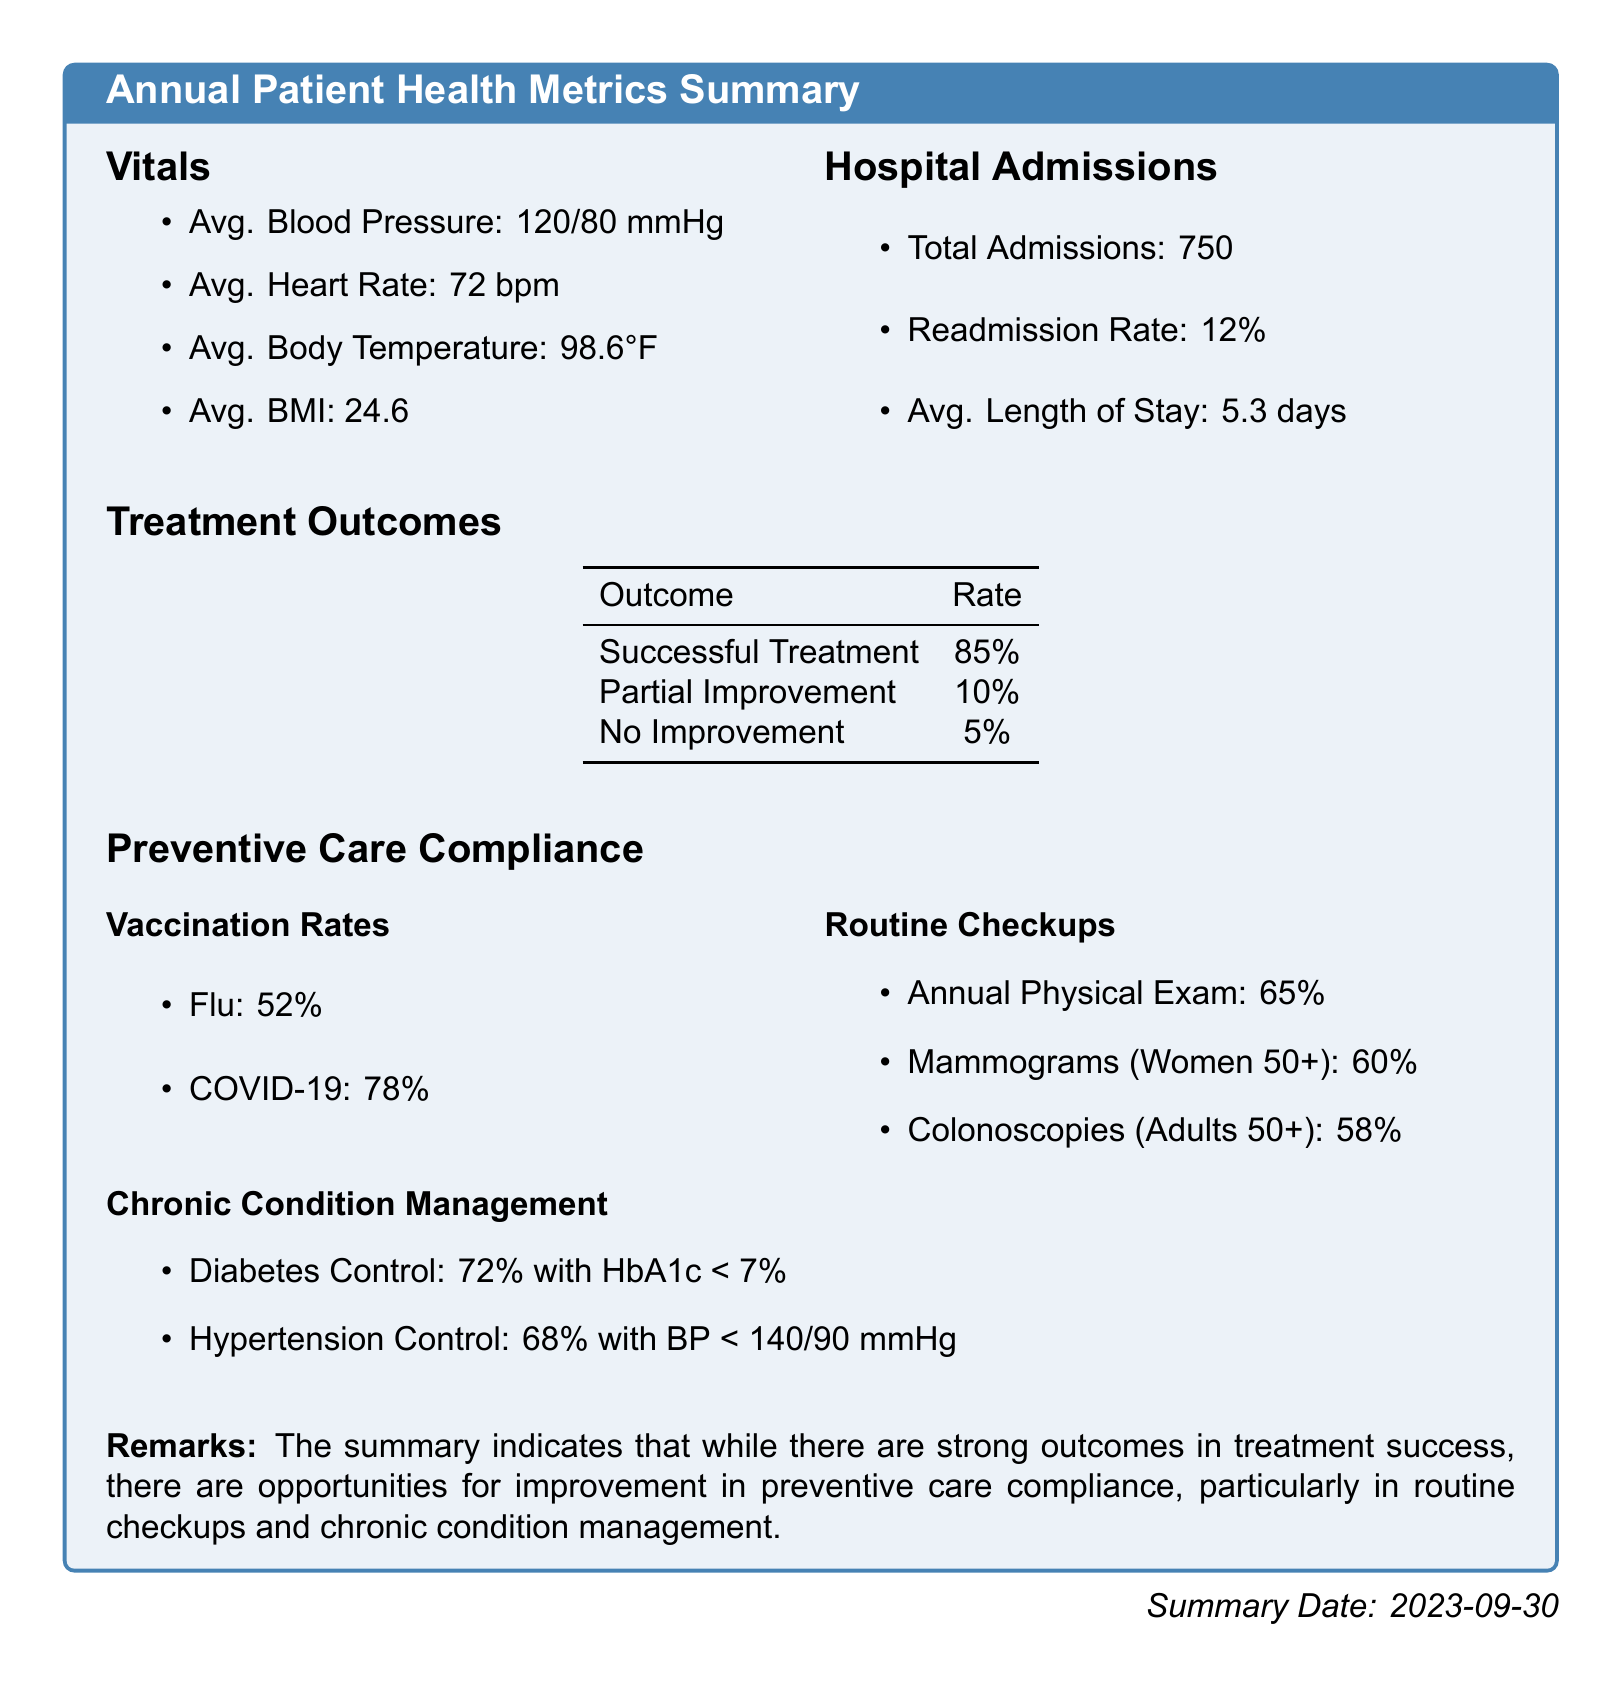what is the average blood pressure? The average blood pressure is stated as 120/80 mmHg in the vitals section.
Answer: 120/80 mmHg what is the total number of hospital admissions? The total hospital admissions are listed as 750 in the hospital admissions section.
Answer: 750 what percentage of patients experienced successful treatment outcomes? The successful treatment rate is provided in the treatment outcomes table as 85%.
Answer: 85% what is the average length of stay for hospital admissions? The average length of stay is mentioned as 5.3 days in the hospital admissions section.
Answer: 5.3 days what is the flu vaccination rate? The flu vaccination rate is noted as 52% in the preventive care compliance section.
Answer: 52% how many percent of patients manage diabetes with HbA1c under 7%? The document states that 72% of patients have diabetes control with HbA1c < 7% in the chronic condition management section.
Answer: 72% what is the readmission rate for hospital admissions? The readmission rate is specified as 12% in the hospital admissions section.
Answer: 12% what percentage of women aged 50 and older received mammograms? The percentage of women aged 50+ who received mammograms is given as 60% in the routine checkups section.
Answer: 60% what is the rate of hypertension control? The rate of hypertension control is stated as 68% with BP < 140/90 mmHg in the chronic condition management section.
Answer: 68% 